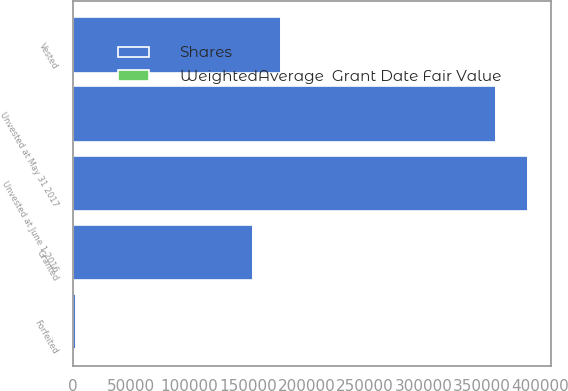<chart> <loc_0><loc_0><loc_500><loc_500><stacked_bar_chart><ecel><fcel>Unvested at June 1 2016<fcel>Granted<fcel>Vested<fcel>Forfeited<fcel>Unvested at May 31 2017<nl><fcel>Shares<fcel>389152<fcel>153984<fcel>177877<fcel>2955<fcel>362304<nl><fcel>WeightedAverage  Grant Date Fair Value<fcel>136.57<fcel>166.12<fcel>123.25<fcel>159.46<fcel>155.53<nl></chart> 